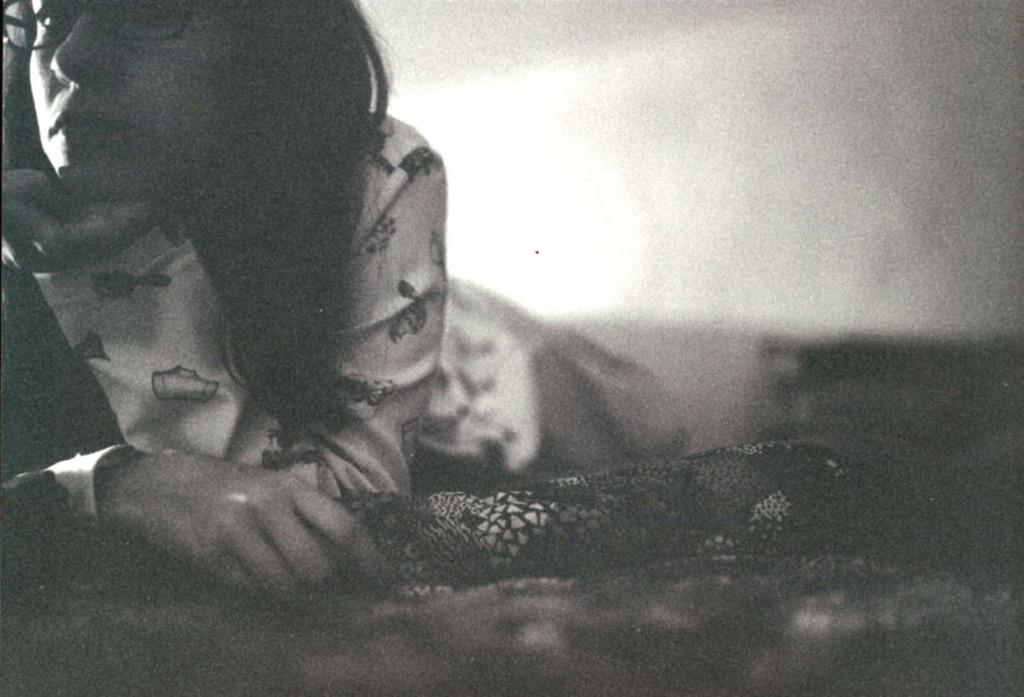Who is present in the image? There is a woman in the picture. What is the woman doing in the image? The woman is lying on the bed. What accessories is the woman wearing in the image? The woman is wearing spectacles. What type of clothing is the woman wearing in the image? The woman is wearing a dress. What type of glove is the woman wearing in the image? There is no glove present in the image; the woman is wearing spectacles. Is there a crook visible in the image? No, there is no crook present in the image. 